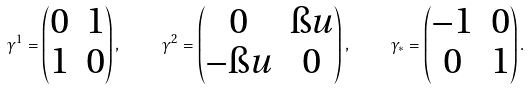<formula> <loc_0><loc_0><loc_500><loc_500>\gamma ^ { 1 } = \left ( \begin{matrix} 0 & 1 \\ 1 & 0 \end{matrix} \right ) , \quad \gamma ^ { 2 } = \left ( \begin{matrix} 0 & \i u \\ - \i u & 0 \end{matrix} \right ) , \quad \gamma _ { * } = \left ( \begin{matrix} - 1 & 0 \\ 0 & 1 \end{matrix} \right ) .</formula> 